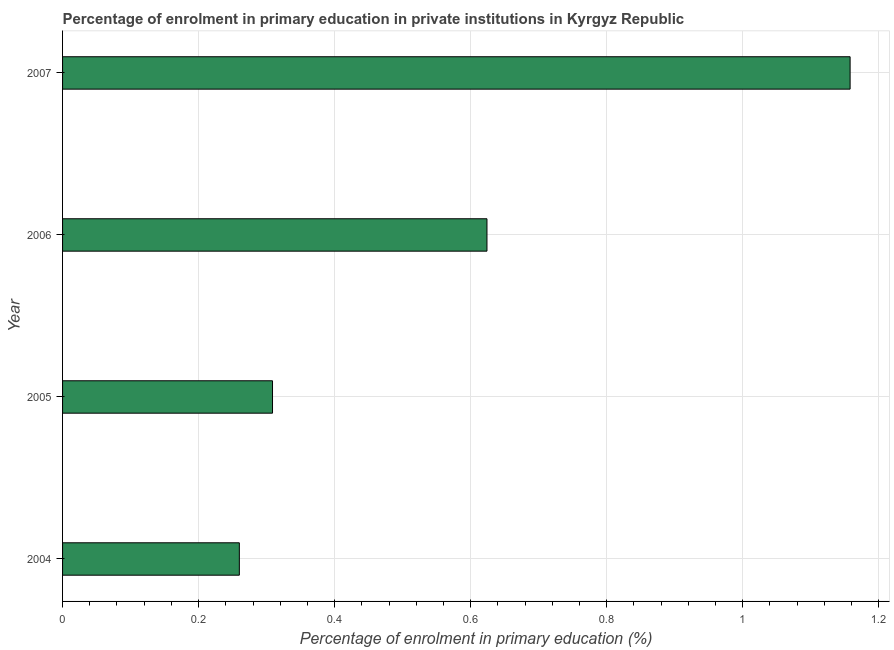What is the title of the graph?
Ensure brevity in your answer.  Percentage of enrolment in primary education in private institutions in Kyrgyz Republic. What is the label or title of the X-axis?
Your answer should be very brief. Percentage of enrolment in primary education (%). What is the label or title of the Y-axis?
Your answer should be very brief. Year. What is the enrolment percentage in primary education in 2007?
Your answer should be very brief. 1.16. Across all years, what is the maximum enrolment percentage in primary education?
Your response must be concise. 1.16. Across all years, what is the minimum enrolment percentage in primary education?
Make the answer very short. 0.26. What is the sum of the enrolment percentage in primary education?
Ensure brevity in your answer.  2.35. What is the difference between the enrolment percentage in primary education in 2004 and 2006?
Provide a short and direct response. -0.36. What is the average enrolment percentage in primary education per year?
Offer a terse response. 0.59. What is the median enrolment percentage in primary education?
Make the answer very short. 0.47. Do a majority of the years between 2006 and 2007 (inclusive) have enrolment percentage in primary education greater than 0.96 %?
Ensure brevity in your answer.  No. What is the ratio of the enrolment percentage in primary education in 2006 to that in 2007?
Ensure brevity in your answer.  0.54. Is the difference between the enrolment percentage in primary education in 2004 and 2006 greater than the difference between any two years?
Offer a terse response. No. What is the difference between the highest and the second highest enrolment percentage in primary education?
Offer a terse response. 0.53. Is the sum of the enrolment percentage in primary education in 2004 and 2006 greater than the maximum enrolment percentage in primary education across all years?
Make the answer very short. No. What is the difference between the highest and the lowest enrolment percentage in primary education?
Your response must be concise. 0.9. In how many years, is the enrolment percentage in primary education greater than the average enrolment percentage in primary education taken over all years?
Provide a succinct answer. 2. How many bars are there?
Ensure brevity in your answer.  4. How many years are there in the graph?
Give a very brief answer. 4. What is the difference between two consecutive major ticks on the X-axis?
Offer a terse response. 0.2. What is the Percentage of enrolment in primary education (%) of 2004?
Your answer should be compact. 0.26. What is the Percentage of enrolment in primary education (%) in 2005?
Your answer should be very brief. 0.31. What is the Percentage of enrolment in primary education (%) of 2006?
Your answer should be compact. 0.62. What is the Percentage of enrolment in primary education (%) of 2007?
Your response must be concise. 1.16. What is the difference between the Percentage of enrolment in primary education (%) in 2004 and 2005?
Your response must be concise. -0.05. What is the difference between the Percentage of enrolment in primary education (%) in 2004 and 2006?
Offer a very short reply. -0.36. What is the difference between the Percentage of enrolment in primary education (%) in 2004 and 2007?
Offer a terse response. -0.9. What is the difference between the Percentage of enrolment in primary education (%) in 2005 and 2006?
Provide a succinct answer. -0.32. What is the difference between the Percentage of enrolment in primary education (%) in 2005 and 2007?
Your answer should be very brief. -0.85. What is the difference between the Percentage of enrolment in primary education (%) in 2006 and 2007?
Ensure brevity in your answer.  -0.53. What is the ratio of the Percentage of enrolment in primary education (%) in 2004 to that in 2005?
Make the answer very short. 0.84. What is the ratio of the Percentage of enrolment in primary education (%) in 2004 to that in 2006?
Your answer should be very brief. 0.42. What is the ratio of the Percentage of enrolment in primary education (%) in 2004 to that in 2007?
Provide a short and direct response. 0.22. What is the ratio of the Percentage of enrolment in primary education (%) in 2005 to that in 2006?
Your answer should be very brief. 0.49. What is the ratio of the Percentage of enrolment in primary education (%) in 2005 to that in 2007?
Your response must be concise. 0.27. What is the ratio of the Percentage of enrolment in primary education (%) in 2006 to that in 2007?
Give a very brief answer. 0.54. 